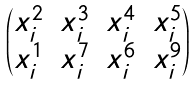Convert formula to latex. <formula><loc_0><loc_0><loc_500><loc_500>\begin{pmatrix} x _ { i } ^ { 2 } & x _ { i } ^ { 3 } & x _ { i } ^ { 4 } & x _ { i } ^ { 5 } \\ x _ { i } ^ { 1 } & x _ { i } ^ { 7 } & x _ { i } ^ { 6 } & x _ { i } ^ { 9 } \end{pmatrix}</formula> 